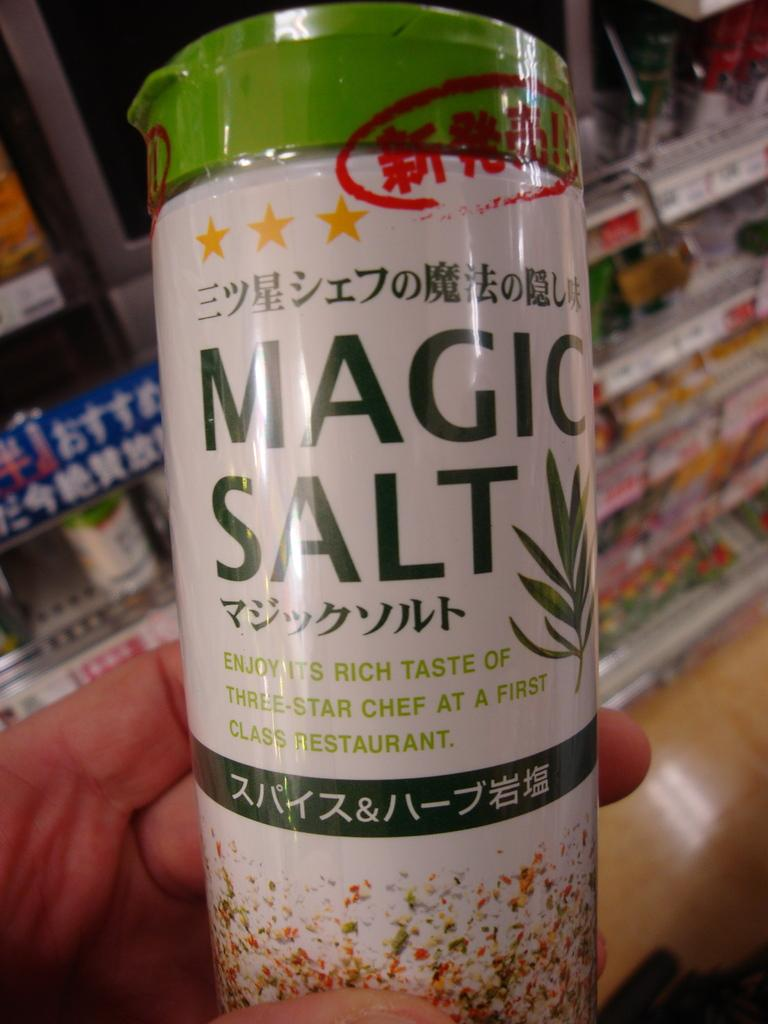<image>
Render a clear and concise summary of the photo. Someone holding up a food product that says Magic Salt on it. 